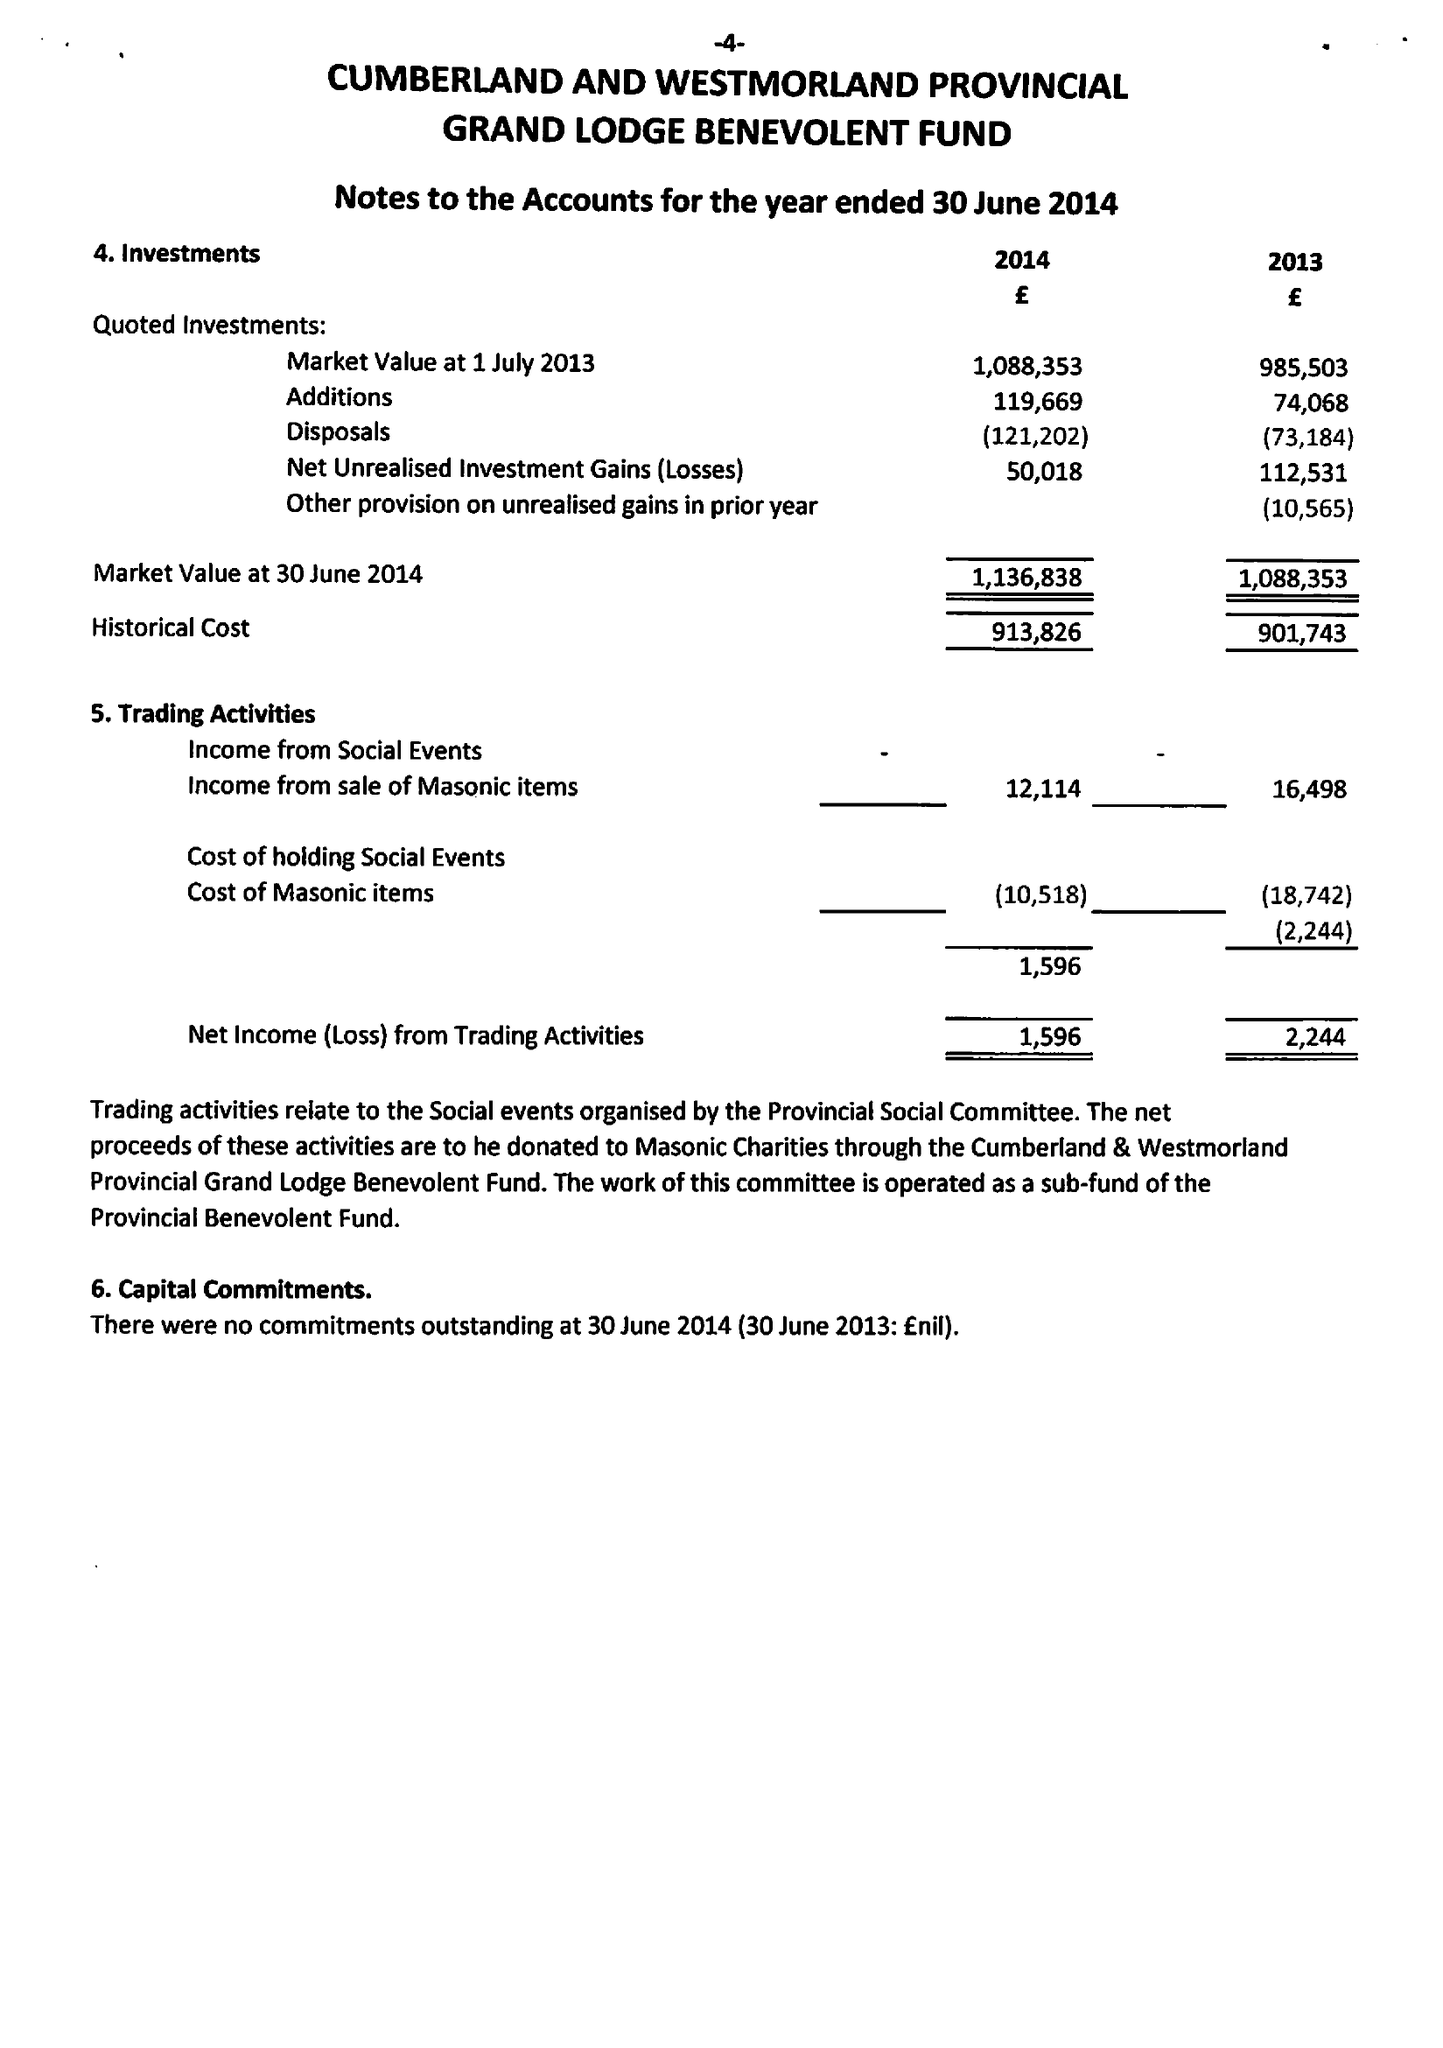What is the value for the charity_name?
Answer the question using a single word or phrase. The Cumberland and Westmorland Provincial Grand Lodge Masonic Benevolent Fund 